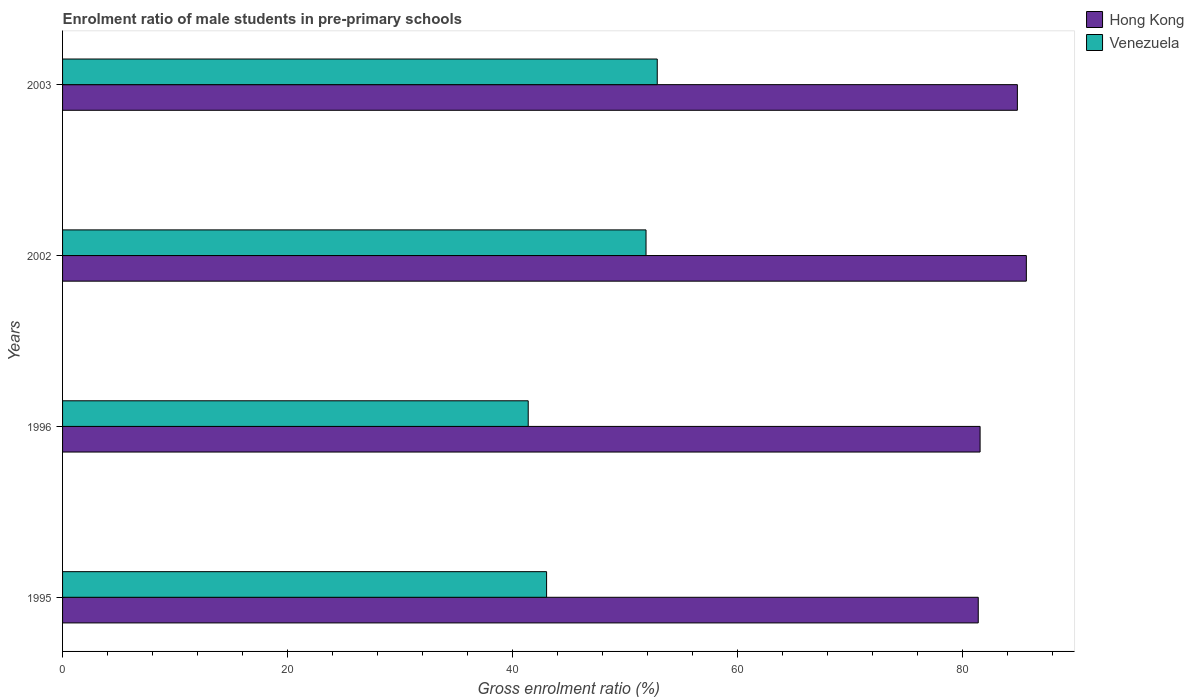How many different coloured bars are there?
Make the answer very short. 2. How many bars are there on the 1st tick from the top?
Make the answer very short. 2. How many bars are there on the 2nd tick from the bottom?
Offer a terse response. 2. What is the enrolment ratio of male students in pre-primary schools in Hong Kong in 2002?
Ensure brevity in your answer.  85.67. Across all years, what is the maximum enrolment ratio of male students in pre-primary schools in Hong Kong?
Offer a very short reply. 85.67. Across all years, what is the minimum enrolment ratio of male students in pre-primary schools in Venezuela?
Keep it short and to the point. 41.39. What is the total enrolment ratio of male students in pre-primary schools in Hong Kong in the graph?
Offer a very short reply. 333.48. What is the difference between the enrolment ratio of male students in pre-primary schools in Venezuela in 1995 and that in 1996?
Your answer should be compact. 1.63. What is the difference between the enrolment ratio of male students in pre-primary schools in Hong Kong in 1996 and the enrolment ratio of male students in pre-primary schools in Venezuela in 2003?
Your answer should be very brief. 28.7. What is the average enrolment ratio of male students in pre-primary schools in Venezuela per year?
Give a very brief answer. 47.28. In the year 2002, what is the difference between the enrolment ratio of male students in pre-primary schools in Hong Kong and enrolment ratio of male students in pre-primary schools in Venezuela?
Provide a succinct answer. 33.81. In how many years, is the enrolment ratio of male students in pre-primary schools in Venezuela greater than 68 %?
Your answer should be compact. 0. What is the ratio of the enrolment ratio of male students in pre-primary schools in Hong Kong in 1995 to that in 2003?
Make the answer very short. 0.96. Is the enrolment ratio of male students in pre-primary schools in Venezuela in 1996 less than that in 2002?
Make the answer very short. Yes. Is the difference between the enrolment ratio of male students in pre-primary schools in Hong Kong in 1995 and 2002 greater than the difference between the enrolment ratio of male students in pre-primary schools in Venezuela in 1995 and 2002?
Keep it short and to the point. Yes. What is the difference between the highest and the second highest enrolment ratio of male students in pre-primary schools in Venezuela?
Provide a succinct answer. 1. What is the difference between the highest and the lowest enrolment ratio of male students in pre-primary schools in Hong Kong?
Make the answer very short. 4.28. Is the sum of the enrolment ratio of male students in pre-primary schools in Hong Kong in 2002 and 2003 greater than the maximum enrolment ratio of male students in pre-primary schools in Venezuela across all years?
Give a very brief answer. Yes. What does the 1st bar from the top in 2002 represents?
Provide a short and direct response. Venezuela. What does the 2nd bar from the bottom in 2002 represents?
Your response must be concise. Venezuela. How many bars are there?
Your answer should be very brief. 8. Are all the bars in the graph horizontal?
Give a very brief answer. Yes. How many years are there in the graph?
Give a very brief answer. 4. What is the difference between two consecutive major ticks on the X-axis?
Ensure brevity in your answer.  20. Does the graph contain grids?
Ensure brevity in your answer.  No. Where does the legend appear in the graph?
Provide a succinct answer. Top right. How are the legend labels stacked?
Your answer should be compact. Vertical. What is the title of the graph?
Your answer should be compact. Enrolment ratio of male students in pre-primary schools. What is the label or title of the X-axis?
Make the answer very short. Gross enrolment ratio (%). What is the Gross enrolment ratio (%) in Hong Kong in 1995?
Your answer should be very brief. 81.39. What is the Gross enrolment ratio (%) in Venezuela in 1995?
Give a very brief answer. 43.02. What is the Gross enrolment ratio (%) of Hong Kong in 1996?
Ensure brevity in your answer.  81.56. What is the Gross enrolment ratio (%) in Venezuela in 1996?
Offer a very short reply. 41.39. What is the Gross enrolment ratio (%) of Hong Kong in 2002?
Your answer should be very brief. 85.67. What is the Gross enrolment ratio (%) in Venezuela in 2002?
Your response must be concise. 51.86. What is the Gross enrolment ratio (%) of Hong Kong in 2003?
Your answer should be very brief. 84.87. What is the Gross enrolment ratio (%) of Venezuela in 2003?
Your answer should be very brief. 52.86. Across all years, what is the maximum Gross enrolment ratio (%) of Hong Kong?
Ensure brevity in your answer.  85.67. Across all years, what is the maximum Gross enrolment ratio (%) in Venezuela?
Your answer should be very brief. 52.86. Across all years, what is the minimum Gross enrolment ratio (%) of Hong Kong?
Keep it short and to the point. 81.39. Across all years, what is the minimum Gross enrolment ratio (%) in Venezuela?
Keep it short and to the point. 41.39. What is the total Gross enrolment ratio (%) of Hong Kong in the graph?
Your response must be concise. 333.48. What is the total Gross enrolment ratio (%) of Venezuela in the graph?
Ensure brevity in your answer.  189.14. What is the difference between the Gross enrolment ratio (%) in Hong Kong in 1995 and that in 1996?
Your response must be concise. -0.16. What is the difference between the Gross enrolment ratio (%) in Venezuela in 1995 and that in 1996?
Your response must be concise. 1.63. What is the difference between the Gross enrolment ratio (%) of Hong Kong in 1995 and that in 2002?
Give a very brief answer. -4.28. What is the difference between the Gross enrolment ratio (%) of Venezuela in 1995 and that in 2002?
Make the answer very short. -8.84. What is the difference between the Gross enrolment ratio (%) in Hong Kong in 1995 and that in 2003?
Provide a succinct answer. -3.48. What is the difference between the Gross enrolment ratio (%) in Venezuela in 1995 and that in 2003?
Offer a very short reply. -9.84. What is the difference between the Gross enrolment ratio (%) of Hong Kong in 1996 and that in 2002?
Keep it short and to the point. -4.11. What is the difference between the Gross enrolment ratio (%) of Venezuela in 1996 and that in 2002?
Offer a terse response. -10.47. What is the difference between the Gross enrolment ratio (%) of Hong Kong in 1996 and that in 2003?
Provide a succinct answer. -3.31. What is the difference between the Gross enrolment ratio (%) of Venezuela in 1996 and that in 2003?
Make the answer very short. -11.47. What is the difference between the Gross enrolment ratio (%) in Hong Kong in 2002 and that in 2003?
Provide a succinct answer. 0.8. What is the difference between the Gross enrolment ratio (%) of Venezuela in 2002 and that in 2003?
Your response must be concise. -1. What is the difference between the Gross enrolment ratio (%) in Hong Kong in 1995 and the Gross enrolment ratio (%) in Venezuela in 1996?
Offer a terse response. 40. What is the difference between the Gross enrolment ratio (%) of Hong Kong in 1995 and the Gross enrolment ratio (%) of Venezuela in 2002?
Make the answer very short. 29.53. What is the difference between the Gross enrolment ratio (%) in Hong Kong in 1995 and the Gross enrolment ratio (%) in Venezuela in 2003?
Your answer should be very brief. 28.53. What is the difference between the Gross enrolment ratio (%) of Hong Kong in 1996 and the Gross enrolment ratio (%) of Venezuela in 2002?
Ensure brevity in your answer.  29.69. What is the difference between the Gross enrolment ratio (%) in Hong Kong in 1996 and the Gross enrolment ratio (%) in Venezuela in 2003?
Keep it short and to the point. 28.7. What is the difference between the Gross enrolment ratio (%) in Hong Kong in 2002 and the Gross enrolment ratio (%) in Venezuela in 2003?
Offer a very short reply. 32.81. What is the average Gross enrolment ratio (%) of Hong Kong per year?
Make the answer very short. 83.37. What is the average Gross enrolment ratio (%) of Venezuela per year?
Offer a very short reply. 47.28. In the year 1995, what is the difference between the Gross enrolment ratio (%) of Hong Kong and Gross enrolment ratio (%) of Venezuela?
Your answer should be compact. 38.37. In the year 1996, what is the difference between the Gross enrolment ratio (%) in Hong Kong and Gross enrolment ratio (%) in Venezuela?
Give a very brief answer. 40.17. In the year 2002, what is the difference between the Gross enrolment ratio (%) of Hong Kong and Gross enrolment ratio (%) of Venezuela?
Provide a succinct answer. 33.81. In the year 2003, what is the difference between the Gross enrolment ratio (%) of Hong Kong and Gross enrolment ratio (%) of Venezuela?
Offer a terse response. 32.01. What is the ratio of the Gross enrolment ratio (%) in Hong Kong in 1995 to that in 1996?
Offer a terse response. 1. What is the ratio of the Gross enrolment ratio (%) of Venezuela in 1995 to that in 1996?
Ensure brevity in your answer.  1.04. What is the ratio of the Gross enrolment ratio (%) of Hong Kong in 1995 to that in 2002?
Your answer should be compact. 0.95. What is the ratio of the Gross enrolment ratio (%) of Venezuela in 1995 to that in 2002?
Your answer should be compact. 0.83. What is the ratio of the Gross enrolment ratio (%) of Hong Kong in 1995 to that in 2003?
Give a very brief answer. 0.96. What is the ratio of the Gross enrolment ratio (%) in Venezuela in 1995 to that in 2003?
Your answer should be compact. 0.81. What is the ratio of the Gross enrolment ratio (%) in Venezuela in 1996 to that in 2002?
Your response must be concise. 0.8. What is the ratio of the Gross enrolment ratio (%) in Venezuela in 1996 to that in 2003?
Your answer should be compact. 0.78. What is the ratio of the Gross enrolment ratio (%) in Hong Kong in 2002 to that in 2003?
Make the answer very short. 1.01. What is the ratio of the Gross enrolment ratio (%) in Venezuela in 2002 to that in 2003?
Your answer should be very brief. 0.98. What is the difference between the highest and the second highest Gross enrolment ratio (%) in Hong Kong?
Keep it short and to the point. 0.8. What is the difference between the highest and the lowest Gross enrolment ratio (%) in Hong Kong?
Keep it short and to the point. 4.28. What is the difference between the highest and the lowest Gross enrolment ratio (%) of Venezuela?
Your response must be concise. 11.47. 